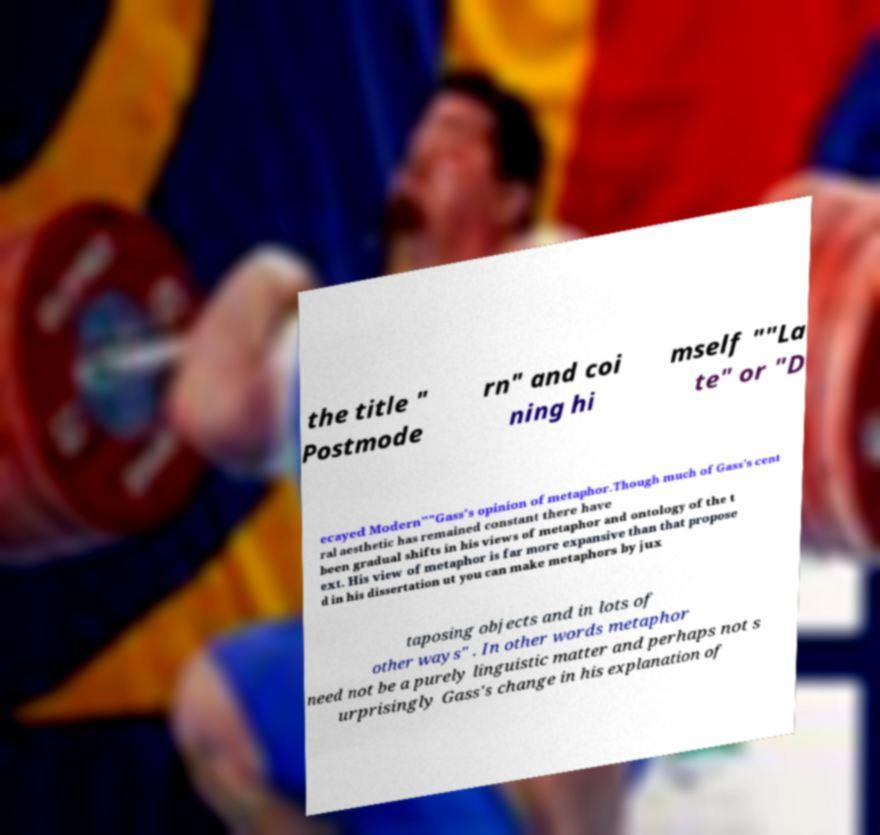Please read and relay the text visible in this image. What does it say? the title " Postmode rn" and coi ning hi mself ""La te" or "D ecayed Modern""Gass's opinion of metaphor.Though much of Gass's cent ral aesthetic has remained constant there have been gradual shifts in his views of metaphor and ontology of the t ext. His view of metaphor is far more expansive than that propose d in his dissertation ut you can make metaphors by jux taposing objects and in lots of other ways" . In other words metaphor need not be a purely linguistic matter and perhaps not s urprisingly Gass's change in his explanation of 